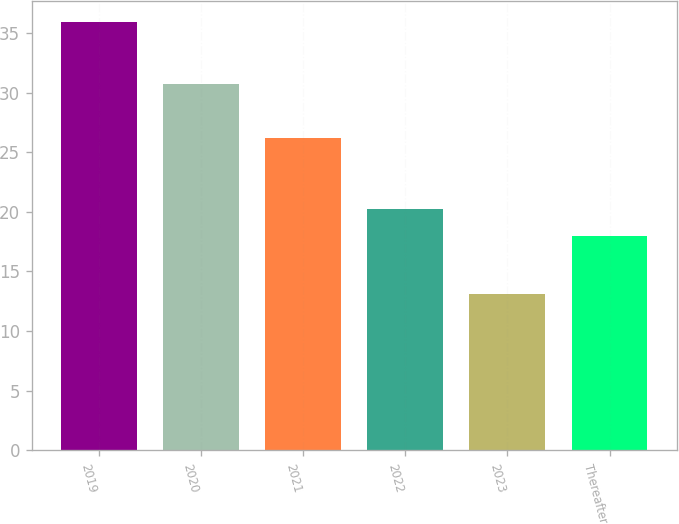Convert chart to OTSL. <chart><loc_0><loc_0><loc_500><loc_500><bar_chart><fcel>2019<fcel>2020<fcel>2021<fcel>2022<fcel>2023<fcel>Thereafter<nl><fcel>35.9<fcel>30.7<fcel>26.2<fcel>20.28<fcel>13.1<fcel>18<nl></chart> 